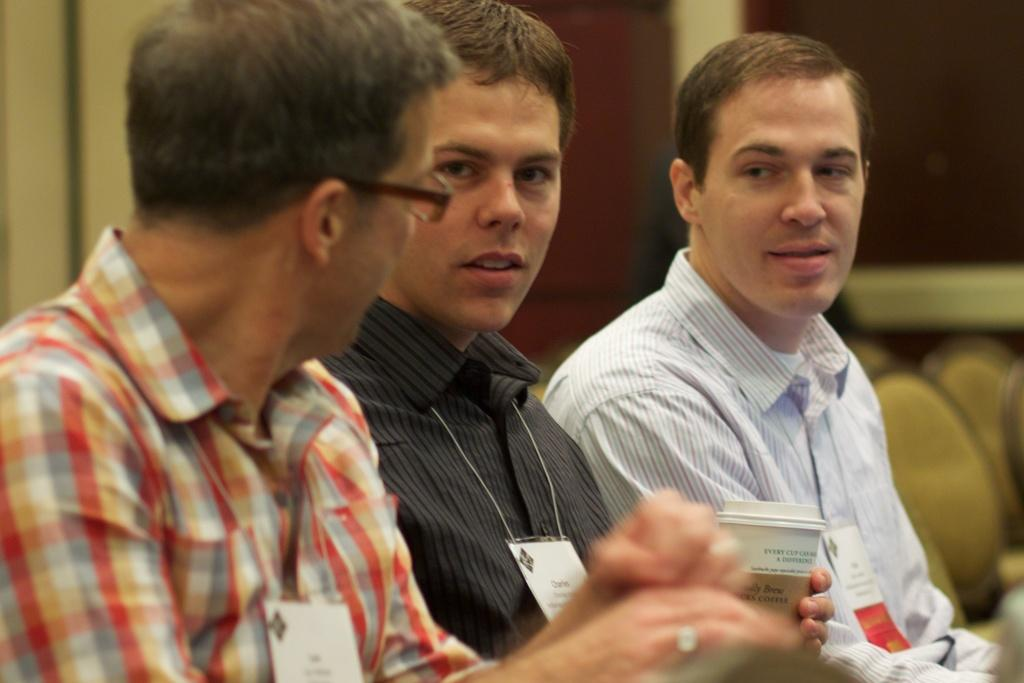What can be observed about the background of the image? The background of the image is blurred. What type of furniture is present in the image? There are chairs in the image. Who is present in the image? There are men in the image. Can you describe the position of one of the men in the image? One man is sitting in the middle of the image. What is the man in the middle holding? The man in the middle is holding a glass. What type of potato is being used as a driving wheel in the image? There is no potato or driving wheel present in the image. How does the man in the middle style his hair in the image? The image does not provide information about the man's hairstyle. 